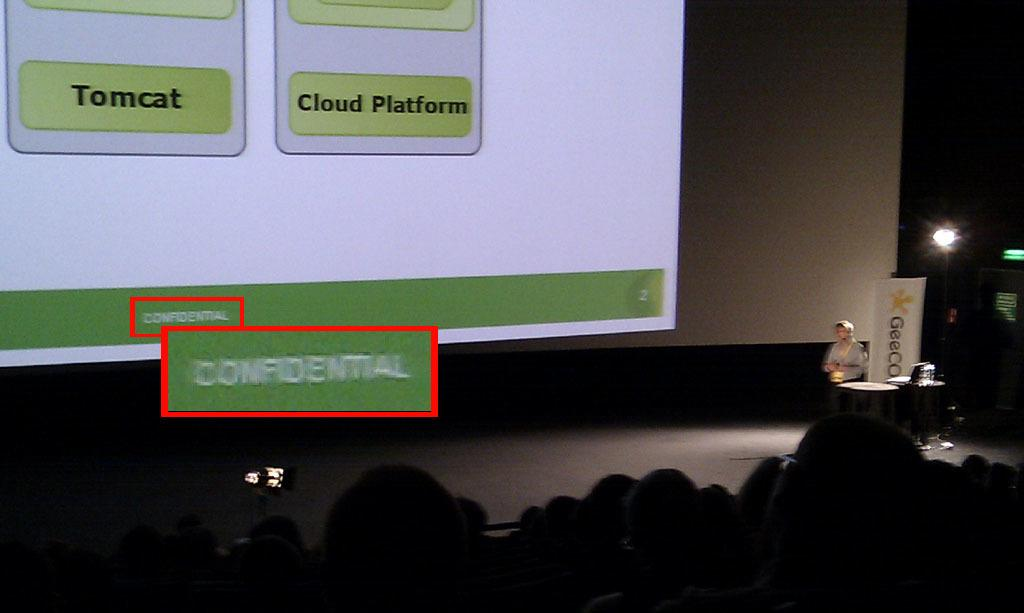Who or what is located on the right side of the image? There is a person standing on the right side of the image. What object can be seen in the image that is often used for presentations or speeches? There is a podium in the image. What can be seen at the bottom of the image? There is a crowd at the bottom of the image. What is present in the background of the image? There is a screen in the background of the image. What can be seen in the image that provides illumination? There is a light in the image. How many cakes are being served to the crowd in the image? There is no mention of cakes in the image; it features a person, a podium, a crowd, a screen, and a light. What type of coach is present in the image? There is no coach present in the image. 